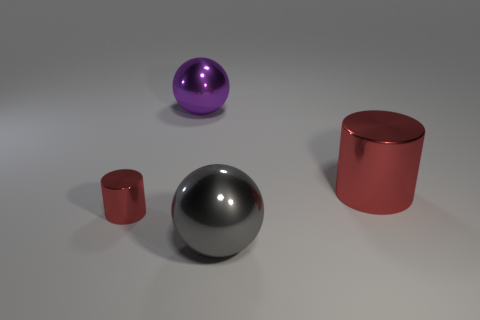Add 4 big gray objects. How many objects exist? 8 Subtract all metal things. Subtract all large green matte objects. How many objects are left? 0 Add 2 big red metal objects. How many big red metal objects are left? 3 Add 2 yellow cylinders. How many yellow cylinders exist? 2 Subtract 0 yellow cubes. How many objects are left? 4 